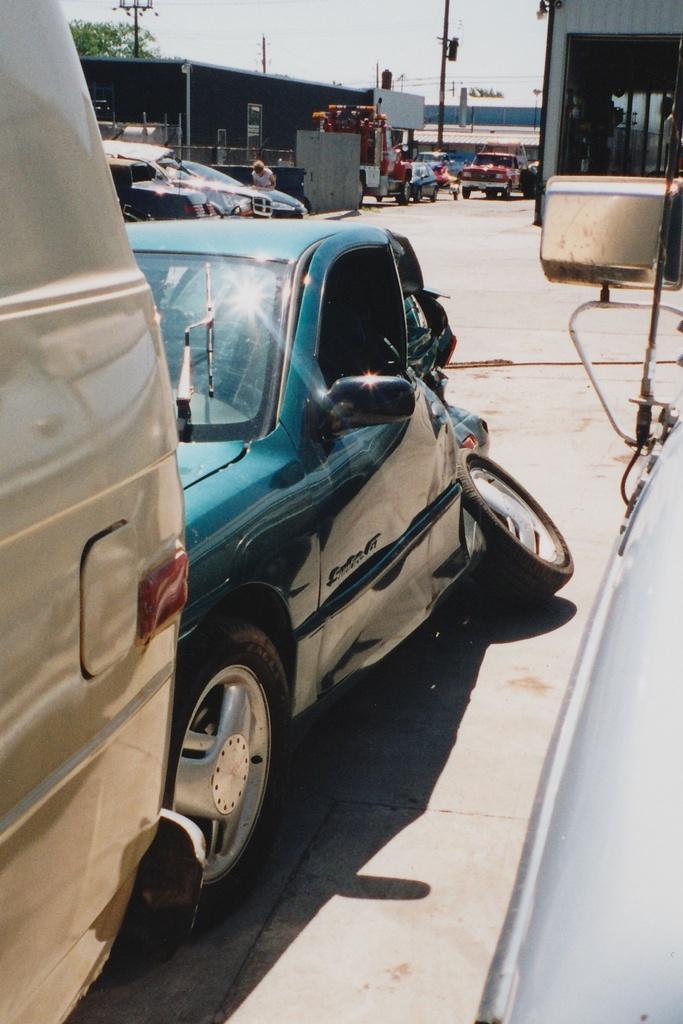Describe this image in one or two sentences. In this image I can see vehicles visible on the road and at the top I can see the sky,pole ,building and vehicle, trees. 